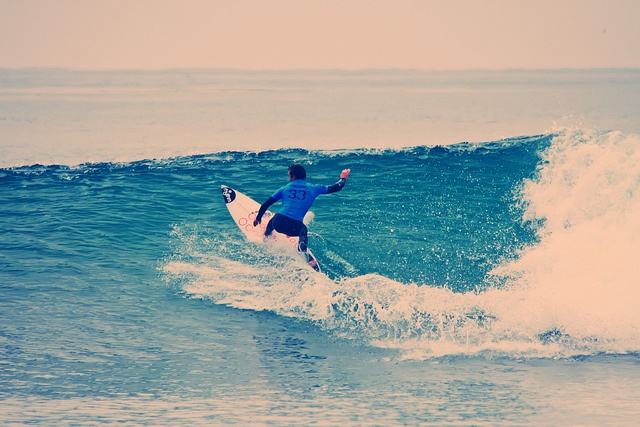Describe the objects in this image and their specific colors. I can see people in tan, navy, blue, darkblue, and teal tones and surfboard in tan, darkgray, and navy tones in this image. 